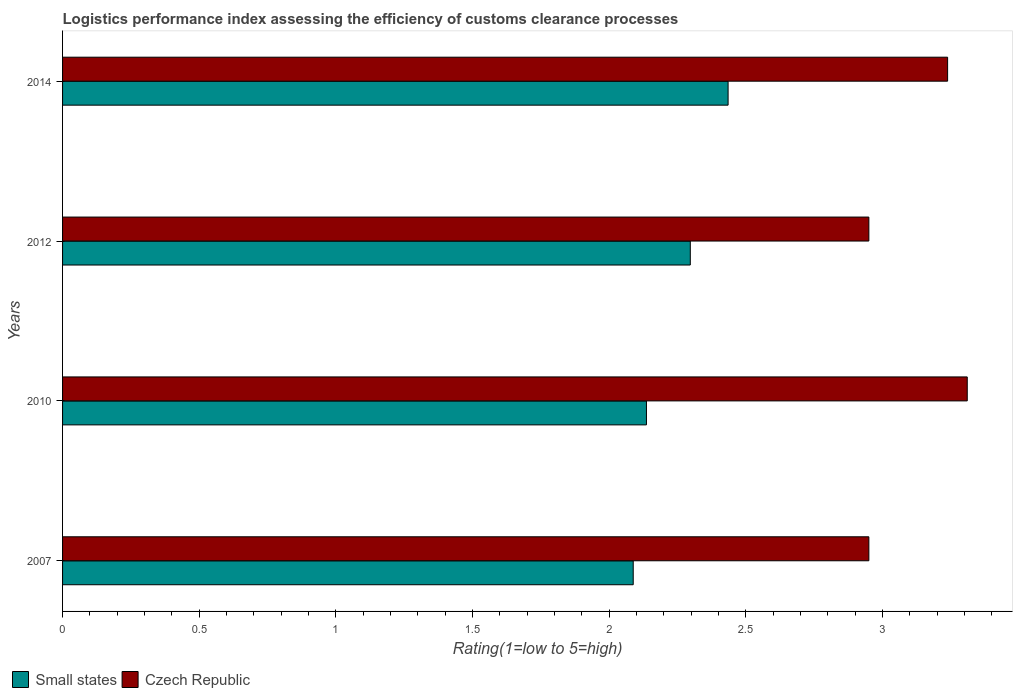How many different coloured bars are there?
Offer a terse response. 2. Are the number of bars per tick equal to the number of legend labels?
Keep it short and to the point. Yes. How many bars are there on the 3rd tick from the bottom?
Ensure brevity in your answer.  2. In how many cases, is the number of bars for a given year not equal to the number of legend labels?
Keep it short and to the point. 0. What is the Logistic performance index in Czech Republic in 2014?
Your answer should be very brief. 3.24. Across all years, what is the maximum Logistic performance index in Small states?
Offer a terse response. 2.43. Across all years, what is the minimum Logistic performance index in Small states?
Give a very brief answer. 2.09. What is the total Logistic performance index in Small states in the graph?
Offer a very short reply. 8.96. What is the difference between the Logistic performance index in Small states in 2007 and that in 2012?
Ensure brevity in your answer.  -0.21. What is the difference between the Logistic performance index in Czech Republic in 2010 and the Logistic performance index in Small states in 2012?
Provide a short and direct response. 1.01. What is the average Logistic performance index in Czech Republic per year?
Keep it short and to the point. 3.11. In the year 2014, what is the difference between the Logistic performance index in Czech Republic and Logistic performance index in Small states?
Provide a succinct answer. 0.8. In how many years, is the Logistic performance index in Czech Republic greater than 2.6 ?
Make the answer very short. 4. What is the ratio of the Logistic performance index in Small states in 2012 to that in 2014?
Your answer should be compact. 0.94. What is the difference between the highest and the second highest Logistic performance index in Czech Republic?
Your response must be concise. 0.07. What is the difference between the highest and the lowest Logistic performance index in Small states?
Give a very brief answer. 0.35. In how many years, is the Logistic performance index in Small states greater than the average Logistic performance index in Small states taken over all years?
Keep it short and to the point. 2. What does the 2nd bar from the top in 2007 represents?
Your answer should be compact. Small states. What does the 1st bar from the bottom in 2014 represents?
Make the answer very short. Small states. How many bars are there?
Your answer should be compact. 8. Are all the bars in the graph horizontal?
Your response must be concise. Yes. How many years are there in the graph?
Offer a very short reply. 4. Are the values on the major ticks of X-axis written in scientific E-notation?
Provide a succinct answer. No. Does the graph contain any zero values?
Provide a short and direct response. No. Where does the legend appear in the graph?
Offer a terse response. Bottom left. What is the title of the graph?
Keep it short and to the point. Logistics performance index assessing the efficiency of customs clearance processes. Does "Denmark" appear as one of the legend labels in the graph?
Provide a short and direct response. No. What is the label or title of the X-axis?
Offer a very short reply. Rating(1=low to 5=high). What is the Rating(1=low to 5=high) of Small states in 2007?
Keep it short and to the point. 2.09. What is the Rating(1=low to 5=high) in Czech Republic in 2007?
Offer a terse response. 2.95. What is the Rating(1=low to 5=high) in Small states in 2010?
Offer a very short reply. 2.14. What is the Rating(1=low to 5=high) in Czech Republic in 2010?
Offer a very short reply. 3.31. What is the Rating(1=low to 5=high) in Small states in 2012?
Keep it short and to the point. 2.3. What is the Rating(1=low to 5=high) of Czech Republic in 2012?
Offer a very short reply. 2.95. What is the Rating(1=low to 5=high) in Small states in 2014?
Give a very brief answer. 2.43. What is the Rating(1=low to 5=high) of Czech Republic in 2014?
Offer a terse response. 3.24. Across all years, what is the maximum Rating(1=low to 5=high) in Small states?
Offer a terse response. 2.43. Across all years, what is the maximum Rating(1=low to 5=high) in Czech Republic?
Your answer should be compact. 3.31. Across all years, what is the minimum Rating(1=low to 5=high) in Small states?
Provide a succinct answer. 2.09. Across all years, what is the minimum Rating(1=low to 5=high) of Czech Republic?
Offer a very short reply. 2.95. What is the total Rating(1=low to 5=high) of Small states in the graph?
Keep it short and to the point. 8.96. What is the total Rating(1=low to 5=high) in Czech Republic in the graph?
Make the answer very short. 12.45. What is the difference between the Rating(1=low to 5=high) in Small states in 2007 and that in 2010?
Your answer should be compact. -0.05. What is the difference between the Rating(1=low to 5=high) in Czech Republic in 2007 and that in 2010?
Your response must be concise. -0.36. What is the difference between the Rating(1=low to 5=high) in Small states in 2007 and that in 2012?
Make the answer very short. -0.21. What is the difference between the Rating(1=low to 5=high) in Small states in 2007 and that in 2014?
Offer a terse response. -0.35. What is the difference between the Rating(1=low to 5=high) in Czech Republic in 2007 and that in 2014?
Offer a very short reply. -0.29. What is the difference between the Rating(1=low to 5=high) in Small states in 2010 and that in 2012?
Provide a succinct answer. -0.16. What is the difference between the Rating(1=low to 5=high) of Czech Republic in 2010 and that in 2012?
Offer a very short reply. 0.36. What is the difference between the Rating(1=low to 5=high) in Small states in 2010 and that in 2014?
Keep it short and to the point. -0.3. What is the difference between the Rating(1=low to 5=high) in Czech Republic in 2010 and that in 2014?
Give a very brief answer. 0.07. What is the difference between the Rating(1=low to 5=high) of Small states in 2012 and that in 2014?
Give a very brief answer. -0.14. What is the difference between the Rating(1=low to 5=high) of Czech Republic in 2012 and that in 2014?
Your answer should be very brief. -0.29. What is the difference between the Rating(1=low to 5=high) in Small states in 2007 and the Rating(1=low to 5=high) in Czech Republic in 2010?
Your response must be concise. -1.22. What is the difference between the Rating(1=low to 5=high) in Small states in 2007 and the Rating(1=low to 5=high) in Czech Republic in 2012?
Ensure brevity in your answer.  -0.86. What is the difference between the Rating(1=low to 5=high) of Small states in 2007 and the Rating(1=low to 5=high) of Czech Republic in 2014?
Give a very brief answer. -1.15. What is the difference between the Rating(1=low to 5=high) in Small states in 2010 and the Rating(1=low to 5=high) in Czech Republic in 2012?
Provide a succinct answer. -0.81. What is the difference between the Rating(1=low to 5=high) of Small states in 2010 and the Rating(1=low to 5=high) of Czech Republic in 2014?
Give a very brief answer. -1.1. What is the difference between the Rating(1=low to 5=high) of Small states in 2012 and the Rating(1=low to 5=high) of Czech Republic in 2014?
Your answer should be very brief. -0.94. What is the average Rating(1=low to 5=high) in Small states per year?
Provide a succinct answer. 2.24. What is the average Rating(1=low to 5=high) in Czech Republic per year?
Provide a short and direct response. 3.11. In the year 2007, what is the difference between the Rating(1=low to 5=high) of Small states and Rating(1=low to 5=high) of Czech Republic?
Provide a succinct answer. -0.86. In the year 2010, what is the difference between the Rating(1=low to 5=high) in Small states and Rating(1=low to 5=high) in Czech Republic?
Your response must be concise. -1.17. In the year 2012, what is the difference between the Rating(1=low to 5=high) in Small states and Rating(1=low to 5=high) in Czech Republic?
Your answer should be very brief. -0.65. In the year 2014, what is the difference between the Rating(1=low to 5=high) of Small states and Rating(1=low to 5=high) of Czech Republic?
Make the answer very short. -0.8. What is the ratio of the Rating(1=low to 5=high) in Small states in 2007 to that in 2010?
Ensure brevity in your answer.  0.98. What is the ratio of the Rating(1=low to 5=high) in Czech Republic in 2007 to that in 2010?
Give a very brief answer. 0.89. What is the ratio of the Rating(1=low to 5=high) in Czech Republic in 2007 to that in 2012?
Ensure brevity in your answer.  1. What is the ratio of the Rating(1=low to 5=high) in Small states in 2007 to that in 2014?
Offer a very short reply. 0.86. What is the ratio of the Rating(1=low to 5=high) in Czech Republic in 2007 to that in 2014?
Offer a very short reply. 0.91. What is the ratio of the Rating(1=low to 5=high) of Small states in 2010 to that in 2012?
Keep it short and to the point. 0.93. What is the ratio of the Rating(1=low to 5=high) in Czech Republic in 2010 to that in 2012?
Provide a succinct answer. 1.12. What is the ratio of the Rating(1=low to 5=high) of Small states in 2010 to that in 2014?
Your answer should be compact. 0.88. What is the ratio of the Rating(1=low to 5=high) in Czech Republic in 2010 to that in 2014?
Offer a very short reply. 1.02. What is the ratio of the Rating(1=low to 5=high) of Small states in 2012 to that in 2014?
Your answer should be compact. 0.94. What is the ratio of the Rating(1=low to 5=high) in Czech Republic in 2012 to that in 2014?
Offer a terse response. 0.91. What is the difference between the highest and the second highest Rating(1=low to 5=high) of Small states?
Your answer should be compact. 0.14. What is the difference between the highest and the second highest Rating(1=low to 5=high) in Czech Republic?
Offer a very short reply. 0.07. What is the difference between the highest and the lowest Rating(1=low to 5=high) of Small states?
Your answer should be very brief. 0.35. What is the difference between the highest and the lowest Rating(1=low to 5=high) in Czech Republic?
Your response must be concise. 0.36. 